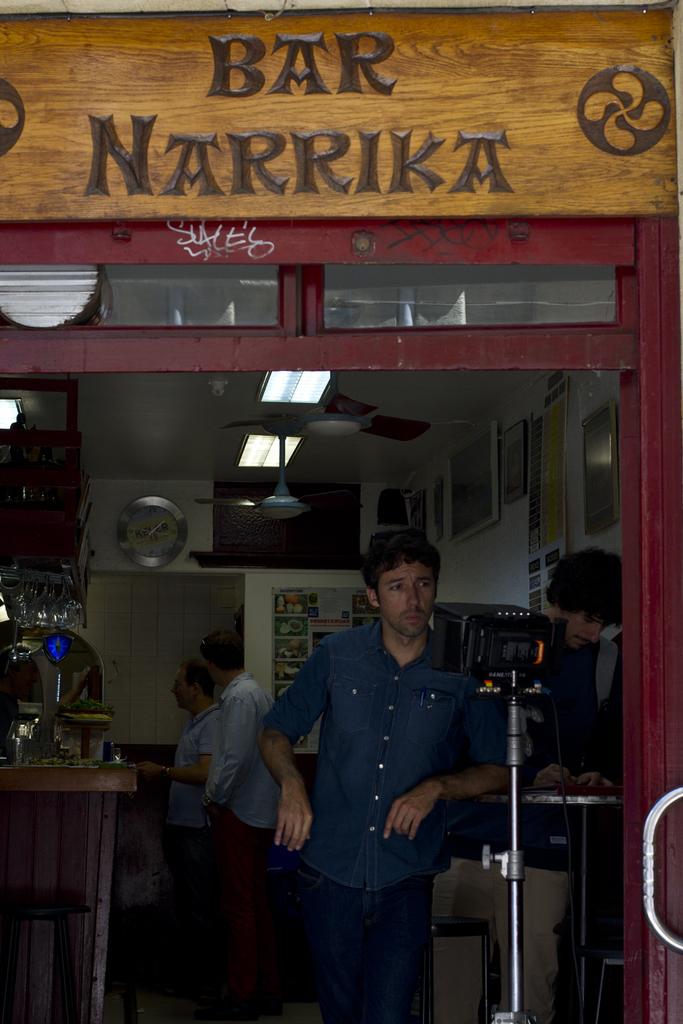What is the name of the bar?
Your response must be concise. Narrika. 